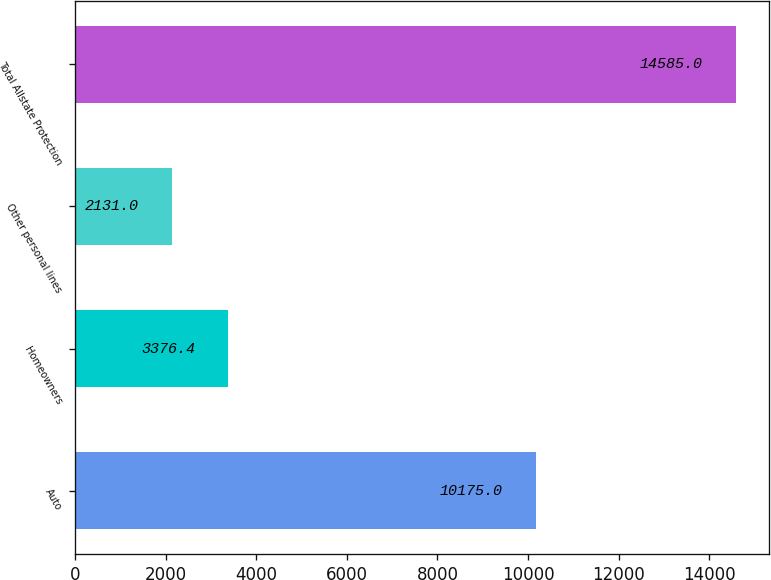<chart> <loc_0><loc_0><loc_500><loc_500><bar_chart><fcel>Auto<fcel>Homeowners<fcel>Other personal lines<fcel>Total Allstate Protection<nl><fcel>10175<fcel>3376.4<fcel>2131<fcel>14585<nl></chart> 